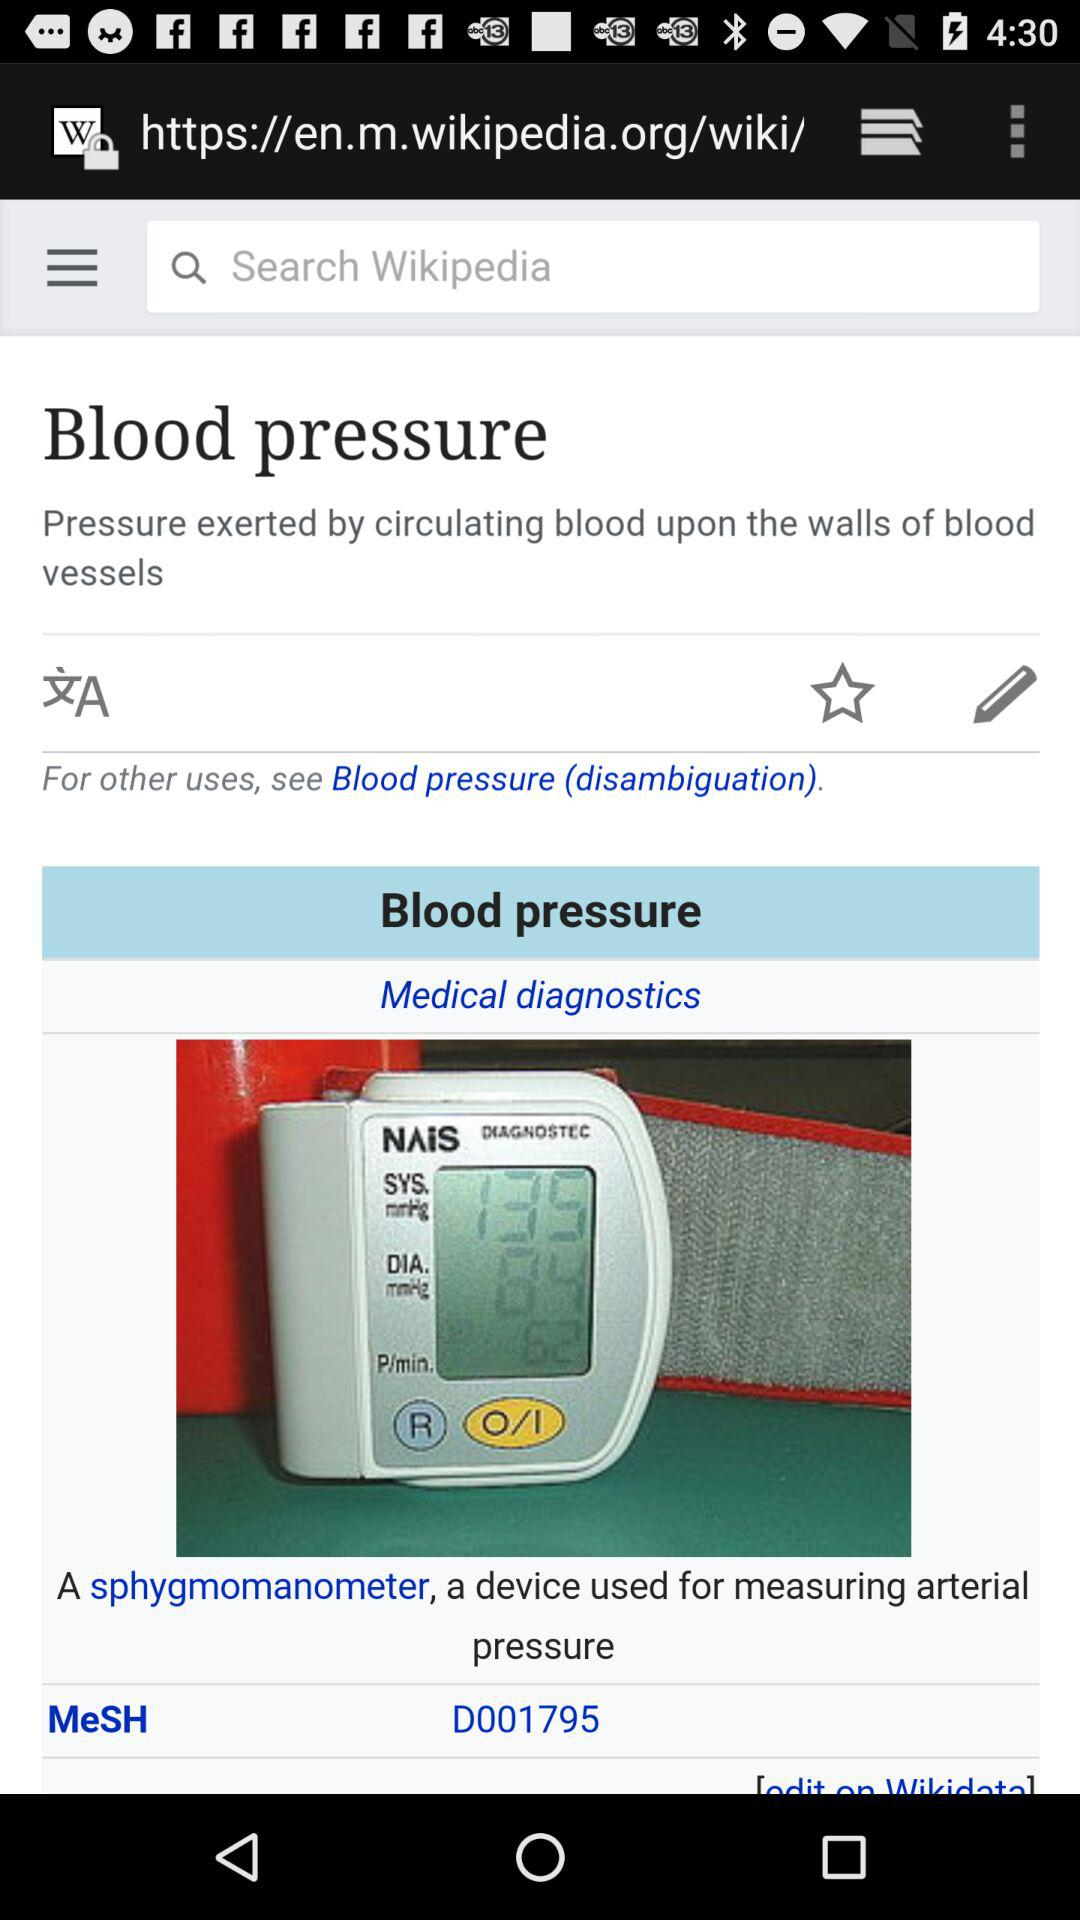What is the pressure per minute? The pressure is 62 per minute. 